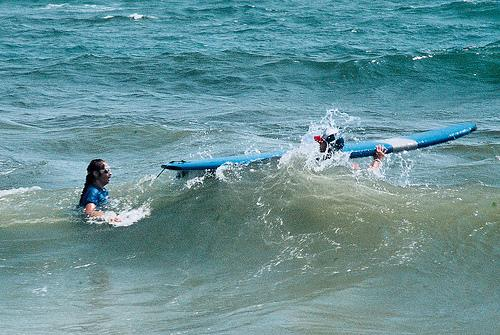Is the ocean water calm or choppy in the image? The ocean water is choppy with small waves. Briefly describe the scene in the image. A man with goggles and a woman wearing a blue shirt are in the ocean water with a blue surfboard, as small waves splash around them. Count the number of people in the image, and describe their appearances. There are two people: one man wearing goggles and a woman with a blue shirt, both submerged in the water up to their chest. Identify the object that the person on the right is holding onto in the image. The person on the right is holding onto a blue surfboard with a silver stripe. Mention a distinctive feature of the surfboard in the image. The surfboard is blue with a silver stripe on it. What action is being performed by the man on the surfboard? The man is holding onto the surfboard while being submerged in the water. Explain the positioning of the man with goggles and the woman in relation to the surfboard. The man with goggles is closer to the surfboard, holding onto it. The woman in the blue shirt is slightly further away and behind the surfboard. What type of water body is depicted in the image? The image depicts an ocean with small waves and white caps. Describe the attire and accessories of the man in the water. The man in the water is wearing swimming goggles and has a surfboard tether strap connected to him. Discuss the patterns seen in the water, such as color and movement. The water is dark blue with gray-green splashes, featuring small waves with white caps and choppy movement. Look for the pink beach ball that's being tossed around by the waves - isn't it a classic beach scene? There is no mention of a pink beach ball in the list of objects and captions, therefore asking to find it is misleading since it doesn't actually exist in the image. Can you find the yellow rubber duck floating in the ocean? It's hard to miss, as it's much brighter than the rest of the scene. There is no mention of a yellow rubber duck in the list of objects and captions, so including it as an object to find is misleading due to its nonexistence in the scene. Check out the fish swimming alongside the people - don't you think they add to the oceanic vibe? No fish are mentioned in the objects and captions provided, so asking the viewer to look for fish is misleading and inaccurate as they don't exist in the image. Do you see the shoreline in the background, with the palm trees and umbrellas? It's such a relaxing spot! There is no shoreline, palm tree, or umbrella mentioned in the list of objects and captions. Asking the viewer to find these objects can be misleading as they are not present in the image. Did you notice the cute dog playing in the water near the people? It seems to be having so much fun! There is no mention of a dog in any of the objects and captions, so including it in the instructions misleads the viewer as they will search for an object not present in the image. Can you spot the bright orange lifebuoy near the surfboard? Safety first, right? There's no mention of an orange lifebuoy in the list of objects and captions, thus making it misleading to ask the viewer to find it since it's not a part of the scene. 